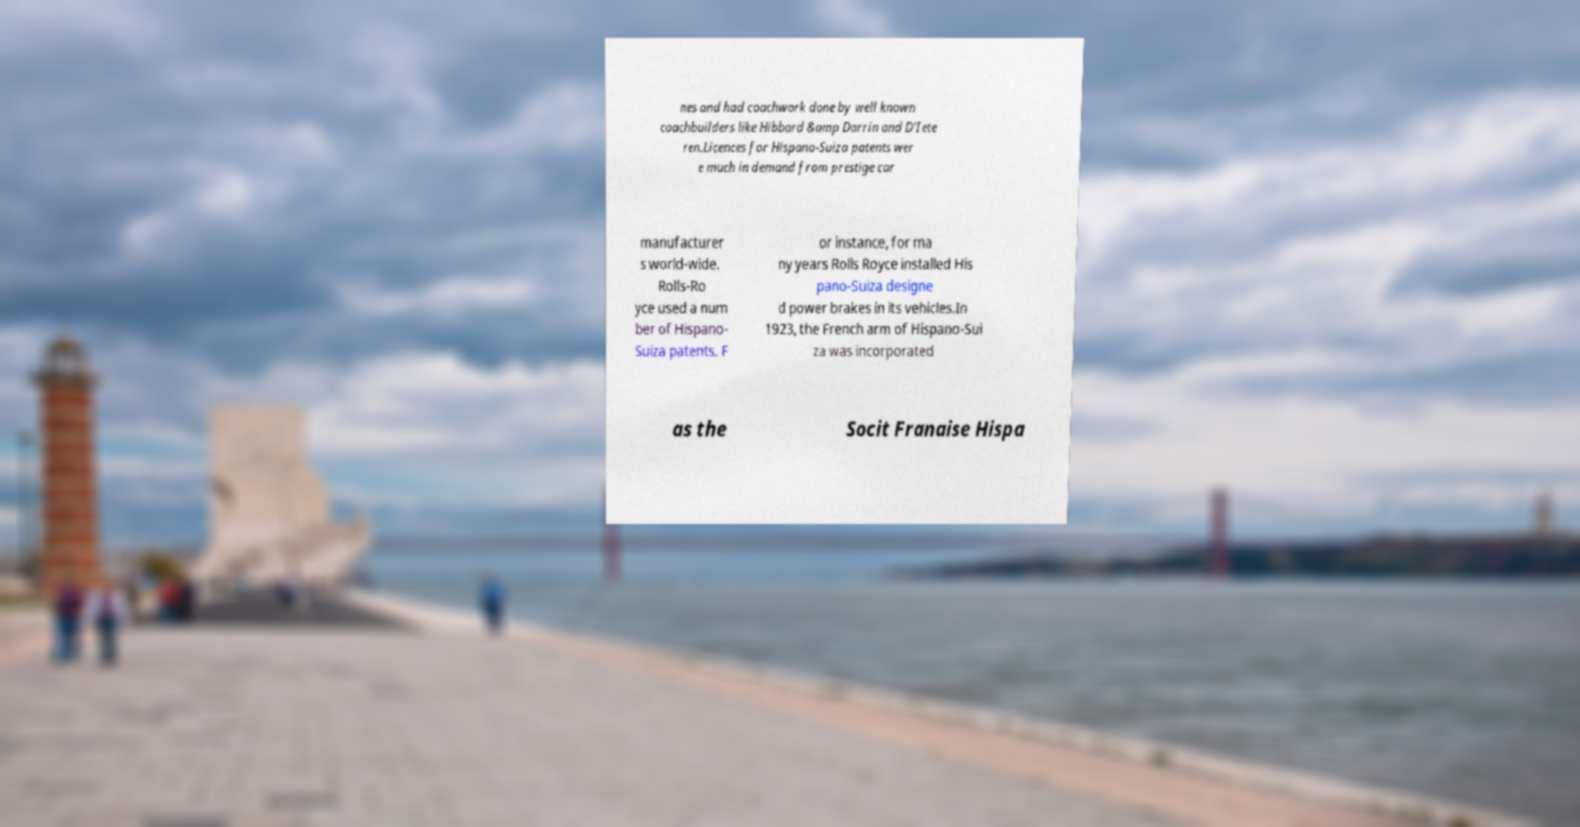Can you accurately transcribe the text from the provided image for me? nes and had coachwork done by well known coachbuilders like Hibbard &amp Darrin and D'Iete ren.Licences for Hispano-Suiza patents wer e much in demand from prestige car manufacturer s world-wide. Rolls-Ro yce used a num ber of Hispano- Suiza patents. F or instance, for ma ny years Rolls Royce installed His pano-Suiza designe d power brakes in its vehicles.In 1923, the French arm of Hispano-Sui za was incorporated as the Socit Franaise Hispa 